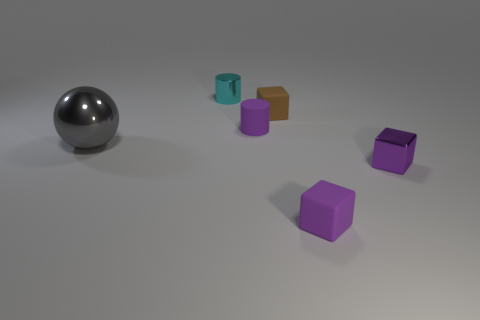Add 4 small cyan metallic things. How many objects exist? 10 Subtract all cylinders. How many objects are left? 4 Subtract 0 brown cylinders. How many objects are left? 6 Subtract all large blue spheres. Subtract all tiny shiny objects. How many objects are left? 4 Add 3 brown things. How many brown things are left? 4 Add 3 small things. How many small things exist? 8 